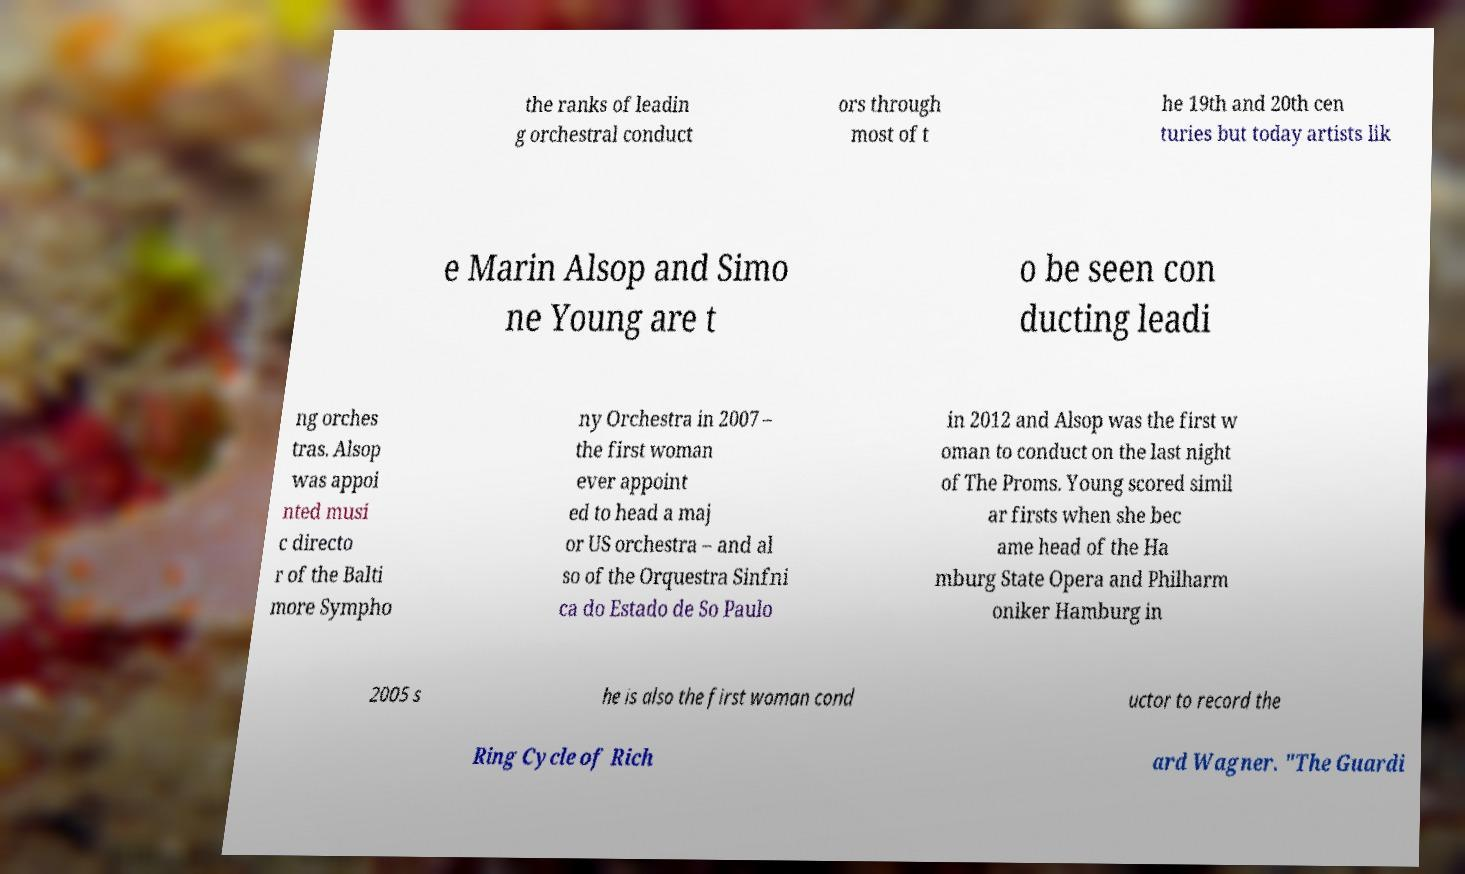For documentation purposes, I need the text within this image transcribed. Could you provide that? the ranks of leadin g orchestral conduct ors through most of t he 19th and 20th cen turies but today artists lik e Marin Alsop and Simo ne Young are t o be seen con ducting leadi ng orches tras. Alsop was appoi nted musi c directo r of the Balti more Sympho ny Orchestra in 2007 – the first woman ever appoint ed to head a maj or US orchestra – and al so of the Orquestra Sinfni ca do Estado de So Paulo in 2012 and Alsop was the first w oman to conduct on the last night of The Proms. Young scored simil ar firsts when she bec ame head of the Ha mburg State Opera and Philharm oniker Hamburg in 2005 s he is also the first woman cond uctor to record the Ring Cycle of Rich ard Wagner. "The Guardi 